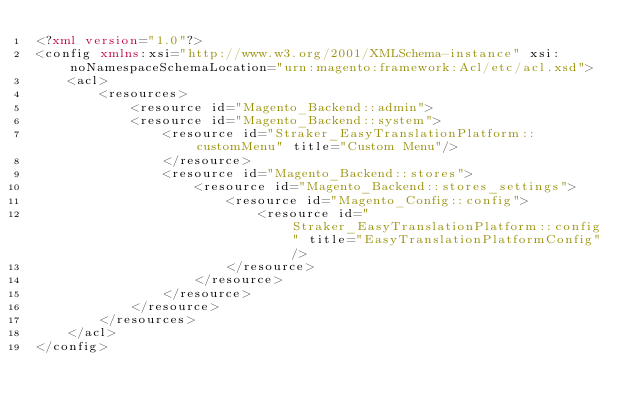<code> <loc_0><loc_0><loc_500><loc_500><_XML_><?xml version="1.0"?>
<config xmlns:xsi="http://www.w3.org/2001/XMLSchema-instance" xsi:noNamespaceSchemaLocation="urn:magento:framework:Acl/etc/acl.xsd">
    <acl>
        <resources>
            <resource id="Magento_Backend::admin">
            <resource id="Magento_Backend::system">
                <resource id="Straker_EasyTranslationPlatform::customMenu" title="Custom Menu"/>
                </resource>
                <resource id="Magento_Backend::stores">
                    <resource id="Magento_Backend::stores_settings">
                        <resource id="Magento_Config::config">
                            <resource id="Straker_EasyTranslationPlatform::config" title="EasyTranslationPlatformConfig"/>
                        </resource>
                    </resource>
                </resource>
            </resource>
        </resources>
    </acl>
</config>
</code> 